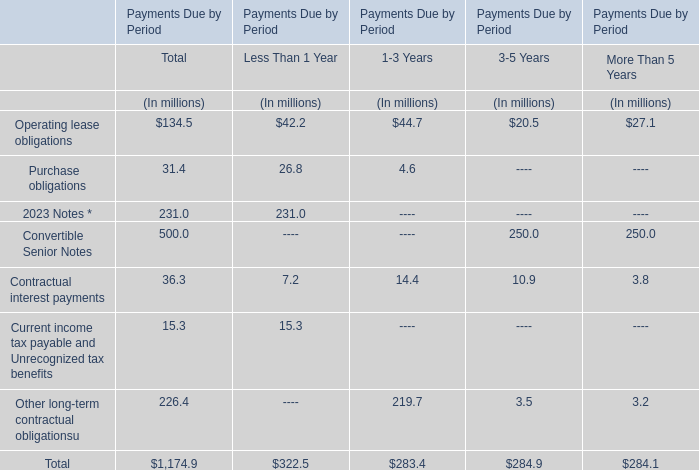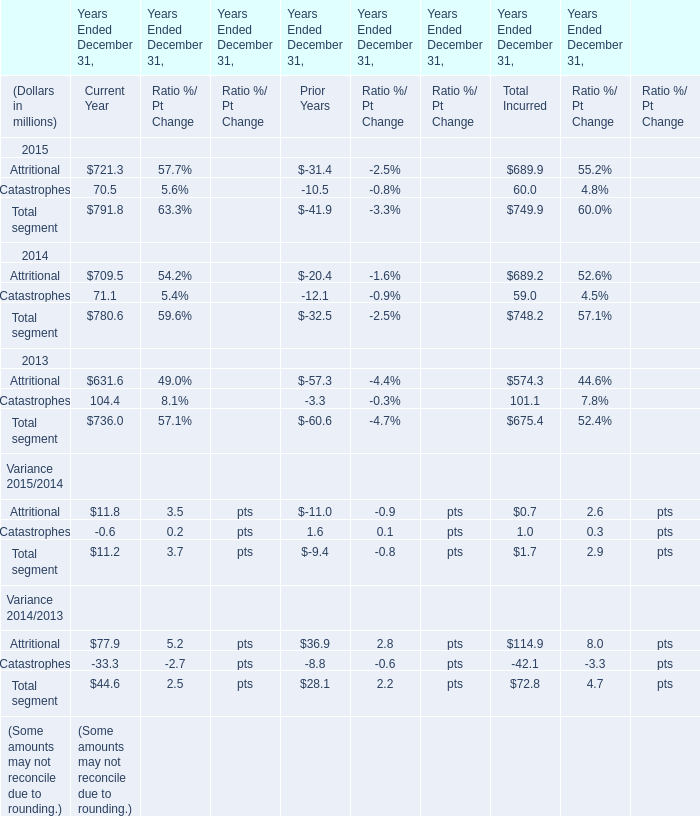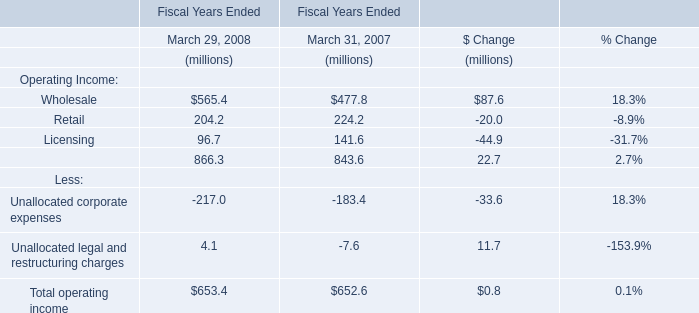As As the chart 1 shows,the value of the amount for Total Incurred for Attritional in which Year Ended December 31 is the largest? 
Answer: 2015. 